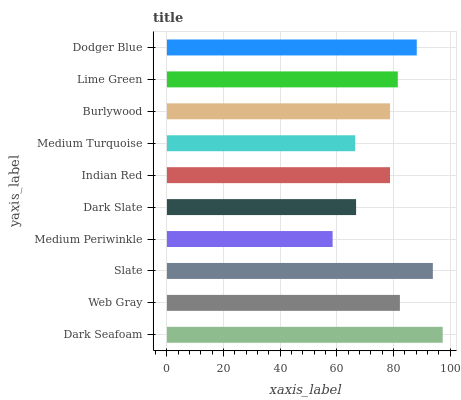Is Medium Periwinkle the minimum?
Answer yes or no. Yes. Is Dark Seafoam the maximum?
Answer yes or no. Yes. Is Web Gray the minimum?
Answer yes or no. No. Is Web Gray the maximum?
Answer yes or no. No. Is Dark Seafoam greater than Web Gray?
Answer yes or no. Yes. Is Web Gray less than Dark Seafoam?
Answer yes or no. Yes. Is Web Gray greater than Dark Seafoam?
Answer yes or no. No. Is Dark Seafoam less than Web Gray?
Answer yes or no. No. Is Lime Green the high median?
Answer yes or no. Yes. Is Burlywood the low median?
Answer yes or no. Yes. Is Dodger Blue the high median?
Answer yes or no. No. Is Indian Red the low median?
Answer yes or no. No. 